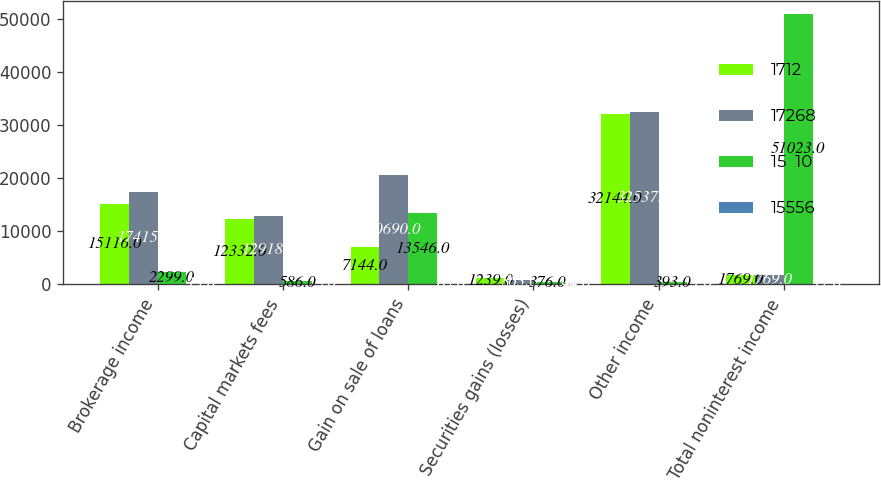<chart> <loc_0><loc_0><loc_500><loc_500><stacked_bar_chart><ecel><fcel>Brokerage income<fcel>Capital markets fees<fcel>Gain on sale of loans<fcel>Securities gains (losses)<fcel>Other income<fcel>Total noninterest income<nl><fcel>1712<fcel>15116<fcel>12332<fcel>7144<fcel>1239<fcel>32144<fcel>1769<nl><fcel>17268<fcel>17415<fcel>12918<fcel>20690<fcel>863<fcel>32537<fcel>1769<nl><fcel>15  10<fcel>2299<fcel>586<fcel>13546<fcel>376<fcel>393<fcel>51023<nl><fcel>15556<fcel>13<fcel>5<fcel>65<fcel>44<fcel>1<fcel>17<nl></chart> 